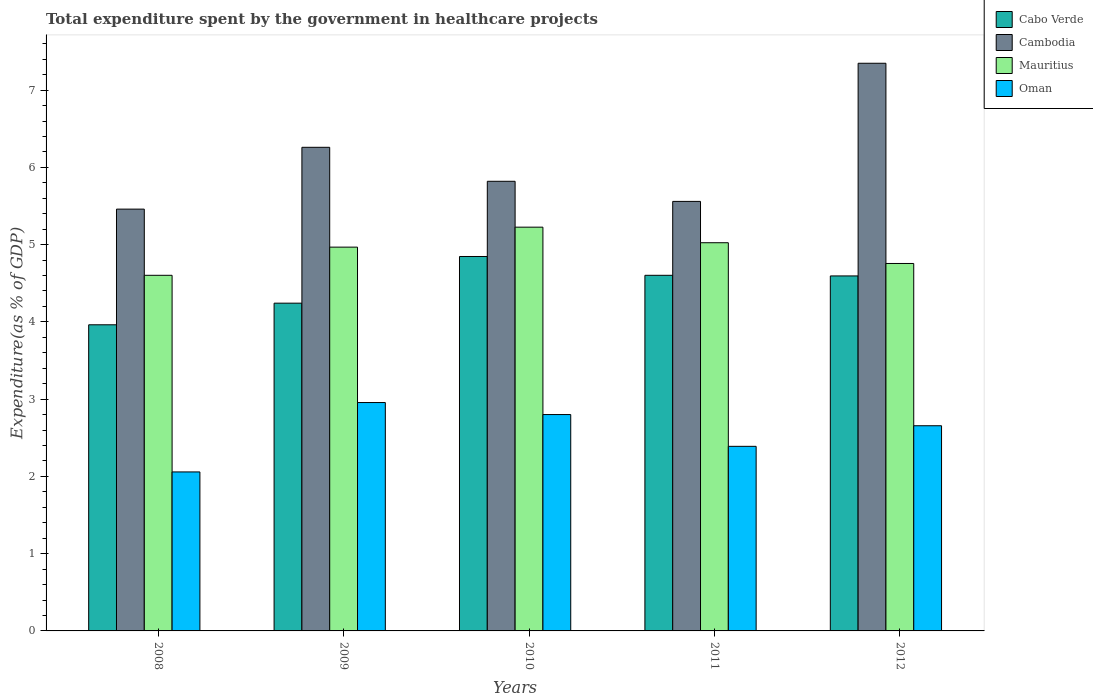Are the number of bars per tick equal to the number of legend labels?
Provide a short and direct response. Yes. Are the number of bars on each tick of the X-axis equal?
Offer a very short reply. Yes. How many bars are there on the 5th tick from the left?
Offer a very short reply. 4. In how many cases, is the number of bars for a given year not equal to the number of legend labels?
Keep it short and to the point. 0. What is the total expenditure spent by the government in healthcare projects in Cabo Verde in 2011?
Ensure brevity in your answer.  4.6. Across all years, what is the maximum total expenditure spent by the government in healthcare projects in Cambodia?
Provide a short and direct response. 7.35. Across all years, what is the minimum total expenditure spent by the government in healthcare projects in Cambodia?
Give a very brief answer. 5.46. What is the total total expenditure spent by the government in healthcare projects in Cabo Verde in the graph?
Provide a succinct answer. 22.25. What is the difference between the total expenditure spent by the government in healthcare projects in Cabo Verde in 2008 and that in 2010?
Offer a very short reply. -0.88. What is the difference between the total expenditure spent by the government in healthcare projects in Oman in 2011 and the total expenditure spent by the government in healthcare projects in Cambodia in 2010?
Your response must be concise. -3.43. What is the average total expenditure spent by the government in healthcare projects in Oman per year?
Offer a very short reply. 2.57. In the year 2009, what is the difference between the total expenditure spent by the government in healthcare projects in Cabo Verde and total expenditure spent by the government in healthcare projects in Cambodia?
Make the answer very short. -2.02. In how many years, is the total expenditure spent by the government in healthcare projects in Mauritius greater than 4.4 %?
Give a very brief answer. 5. What is the ratio of the total expenditure spent by the government in healthcare projects in Oman in 2008 to that in 2011?
Your answer should be compact. 0.86. Is the total expenditure spent by the government in healthcare projects in Mauritius in 2008 less than that in 2011?
Provide a succinct answer. Yes. Is the difference between the total expenditure spent by the government in healthcare projects in Cabo Verde in 2010 and 2012 greater than the difference between the total expenditure spent by the government in healthcare projects in Cambodia in 2010 and 2012?
Your response must be concise. Yes. What is the difference between the highest and the second highest total expenditure spent by the government in healthcare projects in Cabo Verde?
Offer a terse response. 0.24. What is the difference between the highest and the lowest total expenditure spent by the government in healthcare projects in Oman?
Ensure brevity in your answer.  0.9. Is the sum of the total expenditure spent by the government in healthcare projects in Oman in 2008 and 2012 greater than the maximum total expenditure spent by the government in healthcare projects in Mauritius across all years?
Your answer should be compact. No. What does the 1st bar from the left in 2009 represents?
Make the answer very short. Cabo Verde. What does the 3rd bar from the right in 2010 represents?
Make the answer very short. Cambodia. How many bars are there?
Your answer should be compact. 20. Does the graph contain grids?
Your answer should be compact. No. How are the legend labels stacked?
Your answer should be compact. Vertical. What is the title of the graph?
Provide a succinct answer. Total expenditure spent by the government in healthcare projects. What is the label or title of the X-axis?
Ensure brevity in your answer.  Years. What is the label or title of the Y-axis?
Make the answer very short. Expenditure(as % of GDP). What is the Expenditure(as % of GDP) in Cabo Verde in 2008?
Your answer should be compact. 3.96. What is the Expenditure(as % of GDP) of Cambodia in 2008?
Your answer should be compact. 5.46. What is the Expenditure(as % of GDP) of Mauritius in 2008?
Make the answer very short. 4.6. What is the Expenditure(as % of GDP) in Oman in 2008?
Offer a very short reply. 2.06. What is the Expenditure(as % of GDP) in Cabo Verde in 2009?
Ensure brevity in your answer.  4.24. What is the Expenditure(as % of GDP) in Cambodia in 2009?
Give a very brief answer. 6.26. What is the Expenditure(as % of GDP) of Mauritius in 2009?
Your answer should be compact. 4.97. What is the Expenditure(as % of GDP) of Oman in 2009?
Your response must be concise. 2.96. What is the Expenditure(as % of GDP) in Cabo Verde in 2010?
Your response must be concise. 4.85. What is the Expenditure(as % of GDP) in Cambodia in 2010?
Provide a succinct answer. 5.82. What is the Expenditure(as % of GDP) in Mauritius in 2010?
Your response must be concise. 5.23. What is the Expenditure(as % of GDP) in Oman in 2010?
Offer a terse response. 2.8. What is the Expenditure(as % of GDP) of Cabo Verde in 2011?
Offer a terse response. 4.6. What is the Expenditure(as % of GDP) in Cambodia in 2011?
Make the answer very short. 5.56. What is the Expenditure(as % of GDP) of Mauritius in 2011?
Keep it short and to the point. 5.02. What is the Expenditure(as % of GDP) in Oman in 2011?
Your response must be concise. 2.39. What is the Expenditure(as % of GDP) in Cabo Verde in 2012?
Keep it short and to the point. 4.6. What is the Expenditure(as % of GDP) in Cambodia in 2012?
Your answer should be compact. 7.35. What is the Expenditure(as % of GDP) in Mauritius in 2012?
Your answer should be compact. 4.76. What is the Expenditure(as % of GDP) of Oman in 2012?
Your answer should be compact. 2.66. Across all years, what is the maximum Expenditure(as % of GDP) of Cabo Verde?
Provide a succinct answer. 4.85. Across all years, what is the maximum Expenditure(as % of GDP) of Cambodia?
Your response must be concise. 7.35. Across all years, what is the maximum Expenditure(as % of GDP) of Mauritius?
Ensure brevity in your answer.  5.23. Across all years, what is the maximum Expenditure(as % of GDP) in Oman?
Give a very brief answer. 2.96. Across all years, what is the minimum Expenditure(as % of GDP) of Cabo Verde?
Provide a succinct answer. 3.96. Across all years, what is the minimum Expenditure(as % of GDP) of Cambodia?
Ensure brevity in your answer.  5.46. Across all years, what is the minimum Expenditure(as % of GDP) of Mauritius?
Offer a terse response. 4.6. Across all years, what is the minimum Expenditure(as % of GDP) of Oman?
Provide a short and direct response. 2.06. What is the total Expenditure(as % of GDP) in Cabo Verde in the graph?
Your answer should be compact. 22.25. What is the total Expenditure(as % of GDP) in Cambodia in the graph?
Give a very brief answer. 30.45. What is the total Expenditure(as % of GDP) in Mauritius in the graph?
Your answer should be compact. 24.58. What is the total Expenditure(as % of GDP) of Oman in the graph?
Your response must be concise. 12.86. What is the difference between the Expenditure(as % of GDP) of Cabo Verde in 2008 and that in 2009?
Keep it short and to the point. -0.28. What is the difference between the Expenditure(as % of GDP) in Cambodia in 2008 and that in 2009?
Ensure brevity in your answer.  -0.8. What is the difference between the Expenditure(as % of GDP) of Mauritius in 2008 and that in 2009?
Make the answer very short. -0.36. What is the difference between the Expenditure(as % of GDP) of Oman in 2008 and that in 2009?
Offer a terse response. -0.9. What is the difference between the Expenditure(as % of GDP) of Cabo Verde in 2008 and that in 2010?
Offer a very short reply. -0.88. What is the difference between the Expenditure(as % of GDP) in Cambodia in 2008 and that in 2010?
Ensure brevity in your answer.  -0.36. What is the difference between the Expenditure(as % of GDP) of Mauritius in 2008 and that in 2010?
Your answer should be very brief. -0.62. What is the difference between the Expenditure(as % of GDP) of Oman in 2008 and that in 2010?
Offer a terse response. -0.74. What is the difference between the Expenditure(as % of GDP) in Cabo Verde in 2008 and that in 2011?
Your answer should be very brief. -0.64. What is the difference between the Expenditure(as % of GDP) of Cambodia in 2008 and that in 2011?
Give a very brief answer. -0.1. What is the difference between the Expenditure(as % of GDP) in Mauritius in 2008 and that in 2011?
Your answer should be compact. -0.42. What is the difference between the Expenditure(as % of GDP) of Oman in 2008 and that in 2011?
Your response must be concise. -0.33. What is the difference between the Expenditure(as % of GDP) in Cabo Verde in 2008 and that in 2012?
Your answer should be compact. -0.63. What is the difference between the Expenditure(as % of GDP) in Cambodia in 2008 and that in 2012?
Your answer should be compact. -1.89. What is the difference between the Expenditure(as % of GDP) in Mauritius in 2008 and that in 2012?
Provide a short and direct response. -0.15. What is the difference between the Expenditure(as % of GDP) in Oman in 2008 and that in 2012?
Your answer should be very brief. -0.6. What is the difference between the Expenditure(as % of GDP) of Cabo Verde in 2009 and that in 2010?
Ensure brevity in your answer.  -0.6. What is the difference between the Expenditure(as % of GDP) of Cambodia in 2009 and that in 2010?
Provide a succinct answer. 0.44. What is the difference between the Expenditure(as % of GDP) of Mauritius in 2009 and that in 2010?
Offer a terse response. -0.26. What is the difference between the Expenditure(as % of GDP) of Oman in 2009 and that in 2010?
Your response must be concise. 0.16. What is the difference between the Expenditure(as % of GDP) of Cabo Verde in 2009 and that in 2011?
Make the answer very short. -0.36. What is the difference between the Expenditure(as % of GDP) of Cambodia in 2009 and that in 2011?
Make the answer very short. 0.7. What is the difference between the Expenditure(as % of GDP) of Mauritius in 2009 and that in 2011?
Your response must be concise. -0.06. What is the difference between the Expenditure(as % of GDP) of Oman in 2009 and that in 2011?
Provide a short and direct response. 0.57. What is the difference between the Expenditure(as % of GDP) of Cabo Verde in 2009 and that in 2012?
Offer a terse response. -0.35. What is the difference between the Expenditure(as % of GDP) in Cambodia in 2009 and that in 2012?
Offer a terse response. -1.09. What is the difference between the Expenditure(as % of GDP) in Mauritius in 2009 and that in 2012?
Your response must be concise. 0.21. What is the difference between the Expenditure(as % of GDP) of Oman in 2009 and that in 2012?
Provide a succinct answer. 0.3. What is the difference between the Expenditure(as % of GDP) of Cabo Verde in 2010 and that in 2011?
Provide a succinct answer. 0.24. What is the difference between the Expenditure(as % of GDP) in Cambodia in 2010 and that in 2011?
Your answer should be compact. 0.26. What is the difference between the Expenditure(as % of GDP) of Mauritius in 2010 and that in 2011?
Keep it short and to the point. 0.2. What is the difference between the Expenditure(as % of GDP) in Oman in 2010 and that in 2011?
Your answer should be compact. 0.41. What is the difference between the Expenditure(as % of GDP) of Cabo Verde in 2010 and that in 2012?
Your answer should be very brief. 0.25. What is the difference between the Expenditure(as % of GDP) of Cambodia in 2010 and that in 2012?
Offer a terse response. -1.53. What is the difference between the Expenditure(as % of GDP) of Mauritius in 2010 and that in 2012?
Give a very brief answer. 0.47. What is the difference between the Expenditure(as % of GDP) in Oman in 2010 and that in 2012?
Provide a succinct answer. 0.14. What is the difference between the Expenditure(as % of GDP) of Cabo Verde in 2011 and that in 2012?
Ensure brevity in your answer.  0.01. What is the difference between the Expenditure(as % of GDP) of Cambodia in 2011 and that in 2012?
Your answer should be compact. -1.79. What is the difference between the Expenditure(as % of GDP) in Mauritius in 2011 and that in 2012?
Your answer should be very brief. 0.27. What is the difference between the Expenditure(as % of GDP) in Oman in 2011 and that in 2012?
Offer a very short reply. -0.27. What is the difference between the Expenditure(as % of GDP) in Cabo Verde in 2008 and the Expenditure(as % of GDP) in Cambodia in 2009?
Your response must be concise. -2.3. What is the difference between the Expenditure(as % of GDP) in Cabo Verde in 2008 and the Expenditure(as % of GDP) in Mauritius in 2009?
Make the answer very short. -1.01. What is the difference between the Expenditure(as % of GDP) of Cambodia in 2008 and the Expenditure(as % of GDP) of Mauritius in 2009?
Provide a short and direct response. 0.49. What is the difference between the Expenditure(as % of GDP) in Cambodia in 2008 and the Expenditure(as % of GDP) in Oman in 2009?
Make the answer very short. 2.5. What is the difference between the Expenditure(as % of GDP) in Mauritius in 2008 and the Expenditure(as % of GDP) in Oman in 2009?
Your response must be concise. 1.65. What is the difference between the Expenditure(as % of GDP) of Cabo Verde in 2008 and the Expenditure(as % of GDP) of Cambodia in 2010?
Provide a succinct answer. -1.86. What is the difference between the Expenditure(as % of GDP) of Cabo Verde in 2008 and the Expenditure(as % of GDP) of Mauritius in 2010?
Keep it short and to the point. -1.26. What is the difference between the Expenditure(as % of GDP) of Cabo Verde in 2008 and the Expenditure(as % of GDP) of Oman in 2010?
Offer a very short reply. 1.16. What is the difference between the Expenditure(as % of GDP) of Cambodia in 2008 and the Expenditure(as % of GDP) of Mauritius in 2010?
Provide a succinct answer. 0.23. What is the difference between the Expenditure(as % of GDP) in Cambodia in 2008 and the Expenditure(as % of GDP) in Oman in 2010?
Offer a very short reply. 2.66. What is the difference between the Expenditure(as % of GDP) of Mauritius in 2008 and the Expenditure(as % of GDP) of Oman in 2010?
Provide a succinct answer. 1.8. What is the difference between the Expenditure(as % of GDP) of Cabo Verde in 2008 and the Expenditure(as % of GDP) of Cambodia in 2011?
Offer a very short reply. -1.6. What is the difference between the Expenditure(as % of GDP) of Cabo Verde in 2008 and the Expenditure(as % of GDP) of Mauritius in 2011?
Provide a succinct answer. -1.06. What is the difference between the Expenditure(as % of GDP) in Cabo Verde in 2008 and the Expenditure(as % of GDP) in Oman in 2011?
Ensure brevity in your answer.  1.57. What is the difference between the Expenditure(as % of GDP) of Cambodia in 2008 and the Expenditure(as % of GDP) of Mauritius in 2011?
Your answer should be compact. 0.44. What is the difference between the Expenditure(as % of GDP) of Cambodia in 2008 and the Expenditure(as % of GDP) of Oman in 2011?
Provide a succinct answer. 3.07. What is the difference between the Expenditure(as % of GDP) in Mauritius in 2008 and the Expenditure(as % of GDP) in Oman in 2011?
Your answer should be compact. 2.21. What is the difference between the Expenditure(as % of GDP) of Cabo Verde in 2008 and the Expenditure(as % of GDP) of Cambodia in 2012?
Provide a short and direct response. -3.39. What is the difference between the Expenditure(as % of GDP) in Cabo Verde in 2008 and the Expenditure(as % of GDP) in Mauritius in 2012?
Keep it short and to the point. -0.79. What is the difference between the Expenditure(as % of GDP) of Cabo Verde in 2008 and the Expenditure(as % of GDP) of Oman in 2012?
Offer a terse response. 1.31. What is the difference between the Expenditure(as % of GDP) in Cambodia in 2008 and the Expenditure(as % of GDP) in Mauritius in 2012?
Make the answer very short. 0.7. What is the difference between the Expenditure(as % of GDP) of Cambodia in 2008 and the Expenditure(as % of GDP) of Oman in 2012?
Your answer should be compact. 2.8. What is the difference between the Expenditure(as % of GDP) in Mauritius in 2008 and the Expenditure(as % of GDP) in Oman in 2012?
Your response must be concise. 1.95. What is the difference between the Expenditure(as % of GDP) of Cabo Verde in 2009 and the Expenditure(as % of GDP) of Cambodia in 2010?
Your answer should be compact. -1.58. What is the difference between the Expenditure(as % of GDP) of Cabo Verde in 2009 and the Expenditure(as % of GDP) of Mauritius in 2010?
Offer a terse response. -0.98. What is the difference between the Expenditure(as % of GDP) of Cabo Verde in 2009 and the Expenditure(as % of GDP) of Oman in 2010?
Make the answer very short. 1.44. What is the difference between the Expenditure(as % of GDP) in Cambodia in 2009 and the Expenditure(as % of GDP) in Mauritius in 2010?
Provide a succinct answer. 1.03. What is the difference between the Expenditure(as % of GDP) of Cambodia in 2009 and the Expenditure(as % of GDP) of Oman in 2010?
Offer a terse response. 3.46. What is the difference between the Expenditure(as % of GDP) of Mauritius in 2009 and the Expenditure(as % of GDP) of Oman in 2010?
Provide a succinct answer. 2.17. What is the difference between the Expenditure(as % of GDP) of Cabo Verde in 2009 and the Expenditure(as % of GDP) of Cambodia in 2011?
Your answer should be very brief. -1.32. What is the difference between the Expenditure(as % of GDP) in Cabo Verde in 2009 and the Expenditure(as % of GDP) in Mauritius in 2011?
Provide a succinct answer. -0.78. What is the difference between the Expenditure(as % of GDP) in Cabo Verde in 2009 and the Expenditure(as % of GDP) in Oman in 2011?
Ensure brevity in your answer.  1.85. What is the difference between the Expenditure(as % of GDP) of Cambodia in 2009 and the Expenditure(as % of GDP) of Mauritius in 2011?
Your response must be concise. 1.24. What is the difference between the Expenditure(as % of GDP) in Cambodia in 2009 and the Expenditure(as % of GDP) in Oman in 2011?
Offer a very short reply. 3.87. What is the difference between the Expenditure(as % of GDP) in Mauritius in 2009 and the Expenditure(as % of GDP) in Oman in 2011?
Provide a succinct answer. 2.58. What is the difference between the Expenditure(as % of GDP) of Cabo Verde in 2009 and the Expenditure(as % of GDP) of Cambodia in 2012?
Provide a short and direct response. -3.11. What is the difference between the Expenditure(as % of GDP) of Cabo Verde in 2009 and the Expenditure(as % of GDP) of Mauritius in 2012?
Provide a short and direct response. -0.51. What is the difference between the Expenditure(as % of GDP) of Cabo Verde in 2009 and the Expenditure(as % of GDP) of Oman in 2012?
Provide a short and direct response. 1.59. What is the difference between the Expenditure(as % of GDP) of Cambodia in 2009 and the Expenditure(as % of GDP) of Mauritius in 2012?
Provide a short and direct response. 1.5. What is the difference between the Expenditure(as % of GDP) in Cambodia in 2009 and the Expenditure(as % of GDP) in Oman in 2012?
Keep it short and to the point. 3.6. What is the difference between the Expenditure(as % of GDP) of Mauritius in 2009 and the Expenditure(as % of GDP) of Oman in 2012?
Provide a succinct answer. 2.31. What is the difference between the Expenditure(as % of GDP) in Cabo Verde in 2010 and the Expenditure(as % of GDP) in Cambodia in 2011?
Make the answer very short. -0.71. What is the difference between the Expenditure(as % of GDP) in Cabo Verde in 2010 and the Expenditure(as % of GDP) in Mauritius in 2011?
Ensure brevity in your answer.  -0.18. What is the difference between the Expenditure(as % of GDP) of Cabo Verde in 2010 and the Expenditure(as % of GDP) of Oman in 2011?
Provide a short and direct response. 2.46. What is the difference between the Expenditure(as % of GDP) of Cambodia in 2010 and the Expenditure(as % of GDP) of Mauritius in 2011?
Provide a short and direct response. 0.8. What is the difference between the Expenditure(as % of GDP) in Cambodia in 2010 and the Expenditure(as % of GDP) in Oman in 2011?
Ensure brevity in your answer.  3.43. What is the difference between the Expenditure(as % of GDP) in Mauritius in 2010 and the Expenditure(as % of GDP) in Oman in 2011?
Offer a terse response. 2.84. What is the difference between the Expenditure(as % of GDP) in Cabo Verde in 2010 and the Expenditure(as % of GDP) in Cambodia in 2012?
Offer a terse response. -2.5. What is the difference between the Expenditure(as % of GDP) of Cabo Verde in 2010 and the Expenditure(as % of GDP) of Mauritius in 2012?
Provide a short and direct response. 0.09. What is the difference between the Expenditure(as % of GDP) of Cabo Verde in 2010 and the Expenditure(as % of GDP) of Oman in 2012?
Make the answer very short. 2.19. What is the difference between the Expenditure(as % of GDP) of Cambodia in 2010 and the Expenditure(as % of GDP) of Mauritius in 2012?
Your answer should be compact. 1.06. What is the difference between the Expenditure(as % of GDP) of Cambodia in 2010 and the Expenditure(as % of GDP) of Oman in 2012?
Your response must be concise. 3.16. What is the difference between the Expenditure(as % of GDP) of Mauritius in 2010 and the Expenditure(as % of GDP) of Oman in 2012?
Keep it short and to the point. 2.57. What is the difference between the Expenditure(as % of GDP) of Cabo Verde in 2011 and the Expenditure(as % of GDP) of Cambodia in 2012?
Offer a terse response. -2.74. What is the difference between the Expenditure(as % of GDP) in Cabo Verde in 2011 and the Expenditure(as % of GDP) in Mauritius in 2012?
Ensure brevity in your answer.  -0.15. What is the difference between the Expenditure(as % of GDP) in Cabo Verde in 2011 and the Expenditure(as % of GDP) in Oman in 2012?
Your answer should be compact. 1.95. What is the difference between the Expenditure(as % of GDP) of Cambodia in 2011 and the Expenditure(as % of GDP) of Mauritius in 2012?
Make the answer very short. 0.8. What is the difference between the Expenditure(as % of GDP) of Cambodia in 2011 and the Expenditure(as % of GDP) of Oman in 2012?
Provide a short and direct response. 2.9. What is the difference between the Expenditure(as % of GDP) of Mauritius in 2011 and the Expenditure(as % of GDP) of Oman in 2012?
Keep it short and to the point. 2.37. What is the average Expenditure(as % of GDP) in Cabo Verde per year?
Make the answer very short. 4.45. What is the average Expenditure(as % of GDP) in Cambodia per year?
Ensure brevity in your answer.  6.09. What is the average Expenditure(as % of GDP) in Mauritius per year?
Provide a succinct answer. 4.92. What is the average Expenditure(as % of GDP) in Oman per year?
Ensure brevity in your answer.  2.57. In the year 2008, what is the difference between the Expenditure(as % of GDP) in Cabo Verde and Expenditure(as % of GDP) in Cambodia?
Offer a terse response. -1.5. In the year 2008, what is the difference between the Expenditure(as % of GDP) of Cabo Verde and Expenditure(as % of GDP) of Mauritius?
Provide a succinct answer. -0.64. In the year 2008, what is the difference between the Expenditure(as % of GDP) in Cabo Verde and Expenditure(as % of GDP) in Oman?
Ensure brevity in your answer.  1.9. In the year 2008, what is the difference between the Expenditure(as % of GDP) of Cambodia and Expenditure(as % of GDP) of Mauritius?
Provide a short and direct response. 0.86. In the year 2008, what is the difference between the Expenditure(as % of GDP) of Cambodia and Expenditure(as % of GDP) of Oman?
Your answer should be very brief. 3.4. In the year 2008, what is the difference between the Expenditure(as % of GDP) of Mauritius and Expenditure(as % of GDP) of Oman?
Make the answer very short. 2.54. In the year 2009, what is the difference between the Expenditure(as % of GDP) of Cabo Verde and Expenditure(as % of GDP) of Cambodia?
Offer a very short reply. -2.02. In the year 2009, what is the difference between the Expenditure(as % of GDP) in Cabo Verde and Expenditure(as % of GDP) in Mauritius?
Ensure brevity in your answer.  -0.73. In the year 2009, what is the difference between the Expenditure(as % of GDP) in Cabo Verde and Expenditure(as % of GDP) in Oman?
Your answer should be very brief. 1.29. In the year 2009, what is the difference between the Expenditure(as % of GDP) in Cambodia and Expenditure(as % of GDP) in Mauritius?
Give a very brief answer. 1.29. In the year 2009, what is the difference between the Expenditure(as % of GDP) in Cambodia and Expenditure(as % of GDP) in Oman?
Your answer should be very brief. 3.3. In the year 2009, what is the difference between the Expenditure(as % of GDP) in Mauritius and Expenditure(as % of GDP) in Oman?
Your answer should be very brief. 2.01. In the year 2010, what is the difference between the Expenditure(as % of GDP) in Cabo Verde and Expenditure(as % of GDP) in Cambodia?
Your response must be concise. -0.97. In the year 2010, what is the difference between the Expenditure(as % of GDP) in Cabo Verde and Expenditure(as % of GDP) in Mauritius?
Offer a terse response. -0.38. In the year 2010, what is the difference between the Expenditure(as % of GDP) of Cabo Verde and Expenditure(as % of GDP) of Oman?
Offer a terse response. 2.05. In the year 2010, what is the difference between the Expenditure(as % of GDP) in Cambodia and Expenditure(as % of GDP) in Mauritius?
Ensure brevity in your answer.  0.59. In the year 2010, what is the difference between the Expenditure(as % of GDP) of Cambodia and Expenditure(as % of GDP) of Oman?
Provide a short and direct response. 3.02. In the year 2010, what is the difference between the Expenditure(as % of GDP) in Mauritius and Expenditure(as % of GDP) in Oman?
Provide a succinct answer. 2.43. In the year 2011, what is the difference between the Expenditure(as % of GDP) in Cabo Verde and Expenditure(as % of GDP) in Cambodia?
Make the answer very short. -0.96. In the year 2011, what is the difference between the Expenditure(as % of GDP) in Cabo Verde and Expenditure(as % of GDP) in Mauritius?
Offer a terse response. -0.42. In the year 2011, what is the difference between the Expenditure(as % of GDP) in Cabo Verde and Expenditure(as % of GDP) in Oman?
Offer a very short reply. 2.21. In the year 2011, what is the difference between the Expenditure(as % of GDP) in Cambodia and Expenditure(as % of GDP) in Mauritius?
Provide a short and direct response. 0.53. In the year 2011, what is the difference between the Expenditure(as % of GDP) in Cambodia and Expenditure(as % of GDP) in Oman?
Your response must be concise. 3.17. In the year 2011, what is the difference between the Expenditure(as % of GDP) in Mauritius and Expenditure(as % of GDP) in Oman?
Your answer should be compact. 2.64. In the year 2012, what is the difference between the Expenditure(as % of GDP) in Cabo Verde and Expenditure(as % of GDP) in Cambodia?
Give a very brief answer. -2.75. In the year 2012, what is the difference between the Expenditure(as % of GDP) in Cabo Verde and Expenditure(as % of GDP) in Mauritius?
Your answer should be very brief. -0.16. In the year 2012, what is the difference between the Expenditure(as % of GDP) in Cabo Verde and Expenditure(as % of GDP) in Oman?
Your answer should be very brief. 1.94. In the year 2012, what is the difference between the Expenditure(as % of GDP) of Cambodia and Expenditure(as % of GDP) of Mauritius?
Offer a very short reply. 2.59. In the year 2012, what is the difference between the Expenditure(as % of GDP) of Cambodia and Expenditure(as % of GDP) of Oman?
Offer a very short reply. 4.69. In the year 2012, what is the difference between the Expenditure(as % of GDP) in Mauritius and Expenditure(as % of GDP) in Oman?
Your response must be concise. 2.1. What is the ratio of the Expenditure(as % of GDP) in Cabo Verde in 2008 to that in 2009?
Keep it short and to the point. 0.93. What is the ratio of the Expenditure(as % of GDP) in Cambodia in 2008 to that in 2009?
Give a very brief answer. 0.87. What is the ratio of the Expenditure(as % of GDP) of Mauritius in 2008 to that in 2009?
Offer a very short reply. 0.93. What is the ratio of the Expenditure(as % of GDP) of Oman in 2008 to that in 2009?
Your answer should be very brief. 0.7. What is the ratio of the Expenditure(as % of GDP) of Cabo Verde in 2008 to that in 2010?
Make the answer very short. 0.82. What is the ratio of the Expenditure(as % of GDP) of Cambodia in 2008 to that in 2010?
Make the answer very short. 0.94. What is the ratio of the Expenditure(as % of GDP) of Mauritius in 2008 to that in 2010?
Make the answer very short. 0.88. What is the ratio of the Expenditure(as % of GDP) of Oman in 2008 to that in 2010?
Give a very brief answer. 0.73. What is the ratio of the Expenditure(as % of GDP) in Cabo Verde in 2008 to that in 2011?
Give a very brief answer. 0.86. What is the ratio of the Expenditure(as % of GDP) in Cambodia in 2008 to that in 2011?
Give a very brief answer. 0.98. What is the ratio of the Expenditure(as % of GDP) of Mauritius in 2008 to that in 2011?
Your response must be concise. 0.92. What is the ratio of the Expenditure(as % of GDP) in Oman in 2008 to that in 2011?
Ensure brevity in your answer.  0.86. What is the ratio of the Expenditure(as % of GDP) in Cabo Verde in 2008 to that in 2012?
Provide a succinct answer. 0.86. What is the ratio of the Expenditure(as % of GDP) of Cambodia in 2008 to that in 2012?
Offer a terse response. 0.74. What is the ratio of the Expenditure(as % of GDP) of Mauritius in 2008 to that in 2012?
Keep it short and to the point. 0.97. What is the ratio of the Expenditure(as % of GDP) of Oman in 2008 to that in 2012?
Your answer should be very brief. 0.77. What is the ratio of the Expenditure(as % of GDP) of Cabo Verde in 2009 to that in 2010?
Make the answer very short. 0.88. What is the ratio of the Expenditure(as % of GDP) in Cambodia in 2009 to that in 2010?
Your answer should be very brief. 1.08. What is the ratio of the Expenditure(as % of GDP) of Mauritius in 2009 to that in 2010?
Keep it short and to the point. 0.95. What is the ratio of the Expenditure(as % of GDP) in Oman in 2009 to that in 2010?
Provide a succinct answer. 1.06. What is the ratio of the Expenditure(as % of GDP) of Cabo Verde in 2009 to that in 2011?
Provide a short and direct response. 0.92. What is the ratio of the Expenditure(as % of GDP) in Cambodia in 2009 to that in 2011?
Give a very brief answer. 1.13. What is the ratio of the Expenditure(as % of GDP) of Oman in 2009 to that in 2011?
Your answer should be compact. 1.24. What is the ratio of the Expenditure(as % of GDP) in Cabo Verde in 2009 to that in 2012?
Give a very brief answer. 0.92. What is the ratio of the Expenditure(as % of GDP) in Cambodia in 2009 to that in 2012?
Your answer should be very brief. 0.85. What is the ratio of the Expenditure(as % of GDP) in Mauritius in 2009 to that in 2012?
Offer a very short reply. 1.04. What is the ratio of the Expenditure(as % of GDP) in Oman in 2009 to that in 2012?
Make the answer very short. 1.11. What is the ratio of the Expenditure(as % of GDP) of Cabo Verde in 2010 to that in 2011?
Your answer should be compact. 1.05. What is the ratio of the Expenditure(as % of GDP) of Cambodia in 2010 to that in 2011?
Your response must be concise. 1.05. What is the ratio of the Expenditure(as % of GDP) of Mauritius in 2010 to that in 2011?
Make the answer very short. 1.04. What is the ratio of the Expenditure(as % of GDP) of Oman in 2010 to that in 2011?
Provide a succinct answer. 1.17. What is the ratio of the Expenditure(as % of GDP) of Cabo Verde in 2010 to that in 2012?
Provide a short and direct response. 1.05. What is the ratio of the Expenditure(as % of GDP) in Cambodia in 2010 to that in 2012?
Make the answer very short. 0.79. What is the ratio of the Expenditure(as % of GDP) in Mauritius in 2010 to that in 2012?
Give a very brief answer. 1.1. What is the ratio of the Expenditure(as % of GDP) of Oman in 2010 to that in 2012?
Offer a very short reply. 1.05. What is the ratio of the Expenditure(as % of GDP) in Cabo Verde in 2011 to that in 2012?
Offer a terse response. 1. What is the ratio of the Expenditure(as % of GDP) of Cambodia in 2011 to that in 2012?
Ensure brevity in your answer.  0.76. What is the ratio of the Expenditure(as % of GDP) of Mauritius in 2011 to that in 2012?
Your answer should be very brief. 1.06. What is the ratio of the Expenditure(as % of GDP) in Oman in 2011 to that in 2012?
Offer a terse response. 0.9. What is the difference between the highest and the second highest Expenditure(as % of GDP) of Cabo Verde?
Ensure brevity in your answer.  0.24. What is the difference between the highest and the second highest Expenditure(as % of GDP) of Cambodia?
Offer a very short reply. 1.09. What is the difference between the highest and the second highest Expenditure(as % of GDP) of Mauritius?
Ensure brevity in your answer.  0.2. What is the difference between the highest and the second highest Expenditure(as % of GDP) of Oman?
Keep it short and to the point. 0.16. What is the difference between the highest and the lowest Expenditure(as % of GDP) in Cabo Verde?
Give a very brief answer. 0.88. What is the difference between the highest and the lowest Expenditure(as % of GDP) of Cambodia?
Your answer should be very brief. 1.89. What is the difference between the highest and the lowest Expenditure(as % of GDP) in Mauritius?
Offer a terse response. 0.62. What is the difference between the highest and the lowest Expenditure(as % of GDP) of Oman?
Provide a succinct answer. 0.9. 